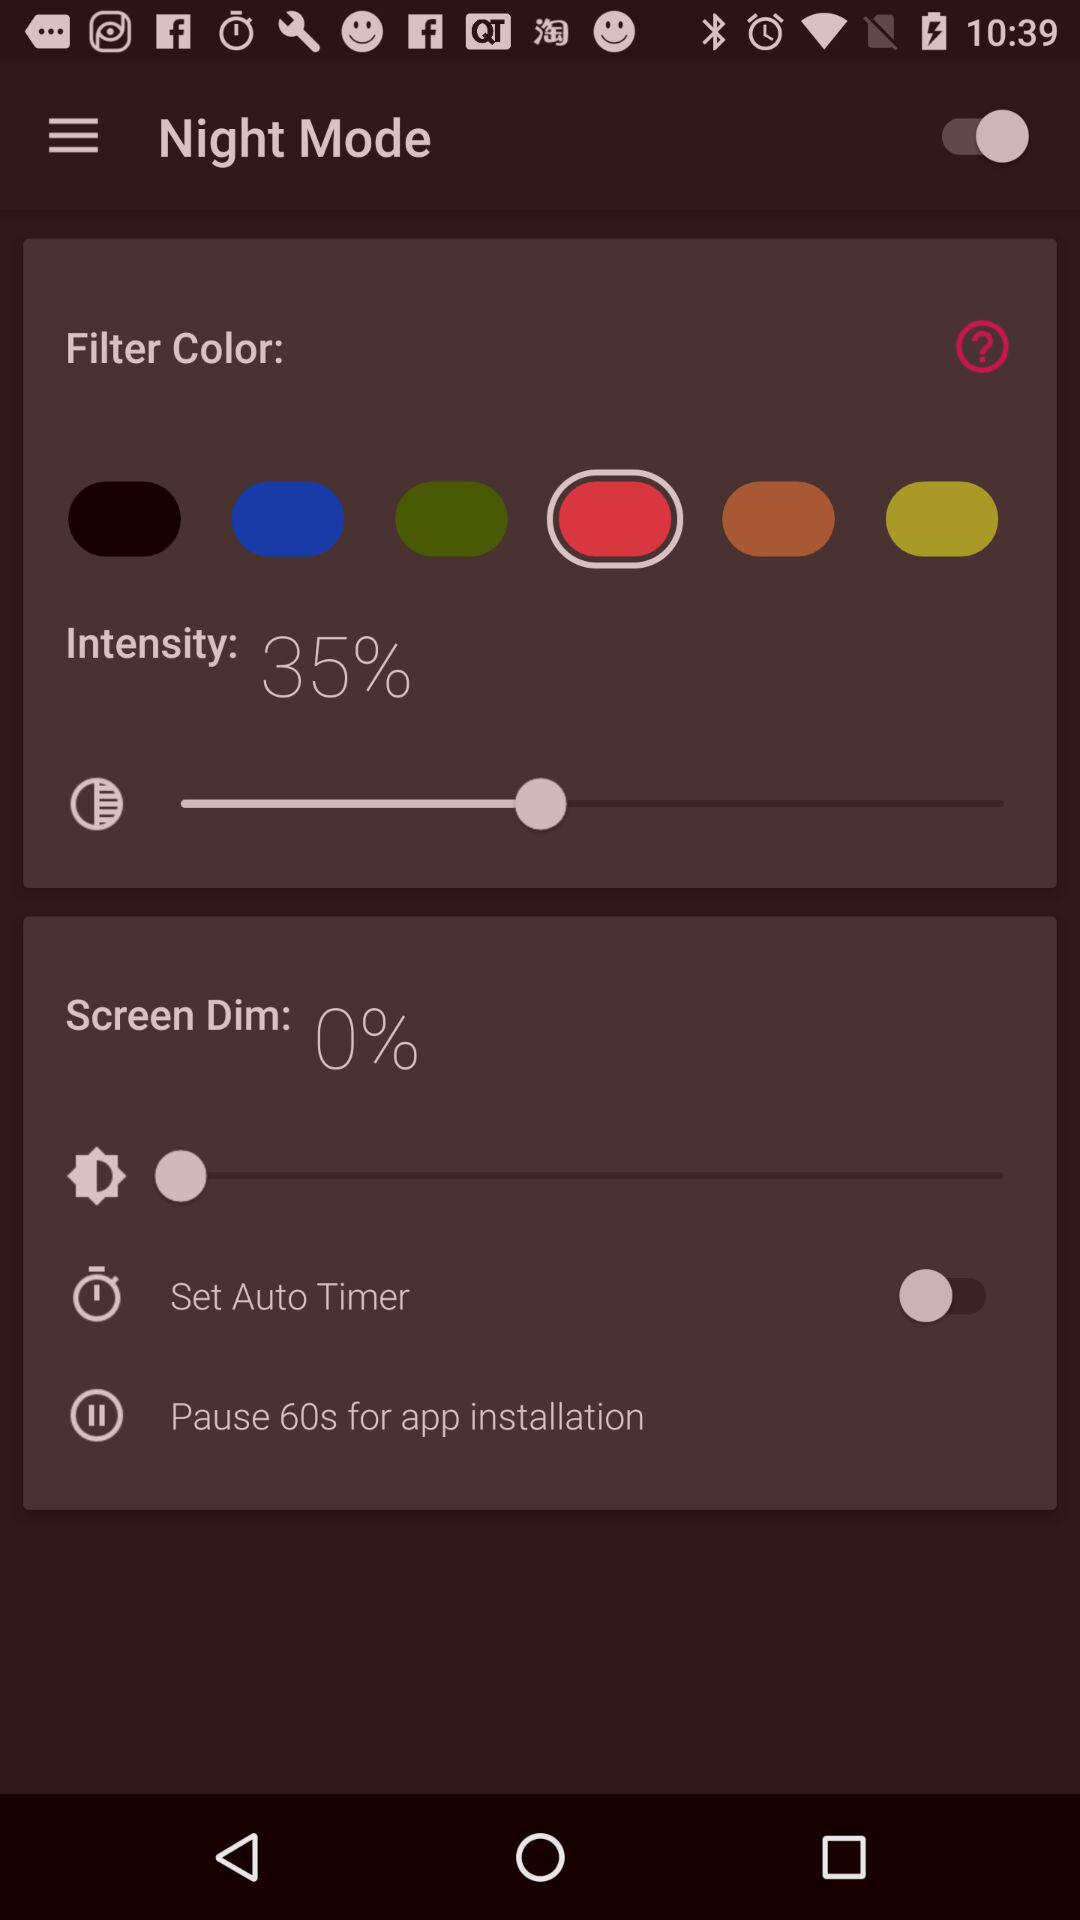What is the status of "Set Auto Timer"? The status is "off". 